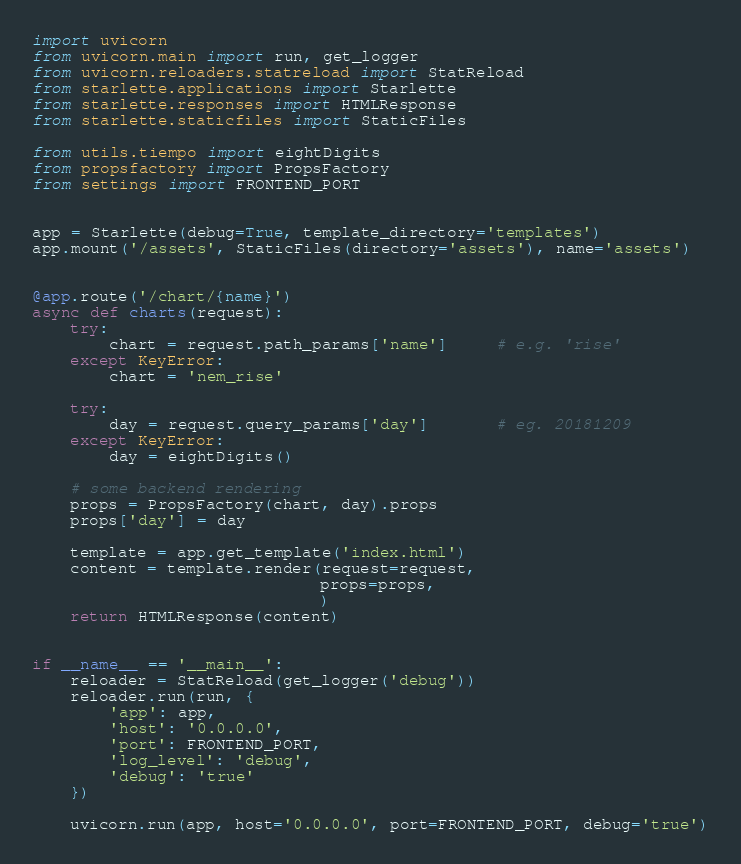<code> <loc_0><loc_0><loc_500><loc_500><_Python_>import uvicorn
from uvicorn.main import run, get_logger
from uvicorn.reloaders.statreload import StatReload
from starlette.applications import Starlette
from starlette.responses import HTMLResponse
from starlette.staticfiles import StaticFiles

from utils.tiempo import eightDigits
from propsfactory import PropsFactory
from settings import FRONTEND_PORT


app = Starlette(debug=True, template_directory='templates')
app.mount('/assets', StaticFiles(directory='assets'), name='assets')


@app.route('/chart/{name}')
async def charts(request):
    try:
        chart = request.path_params['name']     # e.g. 'rise'
    except KeyError:
        chart = 'nem_rise'

    try:
        day = request.query_params['day']       # eg. 20181209
    except KeyError:
        day = eightDigits()

    # some backend rendering
    props = PropsFactory(chart, day).props
    props['day'] = day

    template = app.get_template('index.html')
    content = template.render(request=request,
                              props=props,
                              )
    return HTMLResponse(content)


if __name__ == '__main__':
    reloader = StatReload(get_logger('debug'))
    reloader.run(run, {
        'app': app,
        'host': '0.0.0.0',
        'port': FRONTEND_PORT,
        'log_level': 'debug',
        'debug': 'true'
    })

    uvicorn.run(app, host='0.0.0.0', port=FRONTEND_PORT, debug='true')
</code> 